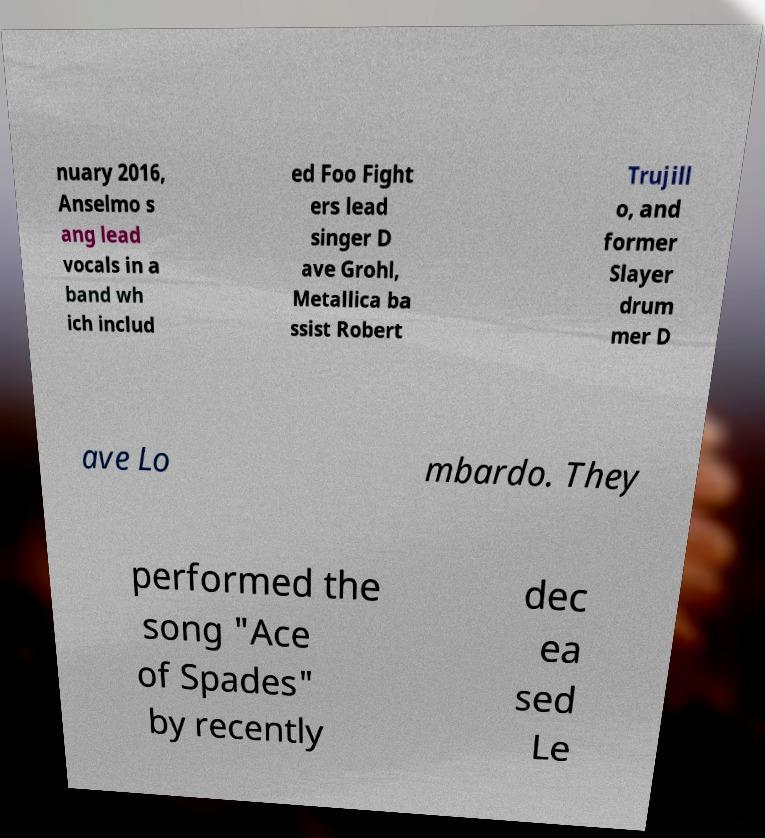Could you assist in decoding the text presented in this image and type it out clearly? nuary 2016, Anselmo s ang lead vocals in a band wh ich includ ed Foo Fight ers lead singer D ave Grohl, Metallica ba ssist Robert Trujill o, and former Slayer drum mer D ave Lo mbardo. They performed the song "Ace of Spades" by recently dec ea sed Le 